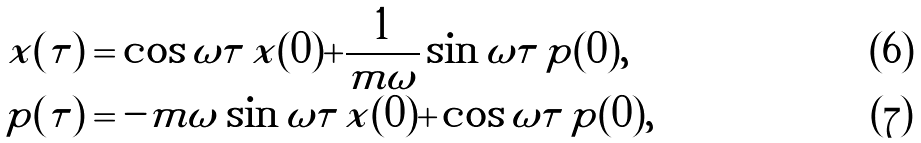<formula> <loc_0><loc_0><loc_500><loc_500>\tilde { x } ( \tau ) & = \cos \omega \tau \, \tilde { x } ( 0 ) + \frac { 1 } { m \omega } \sin \omega \tau \, \tilde { p } ( 0 ) , \\ \tilde { p } ( \tau ) & = - m \omega \sin \omega \tau \, \tilde { x } ( 0 ) + \cos \omega \tau \, \tilde { p } ( 0 ) ,</formula> 